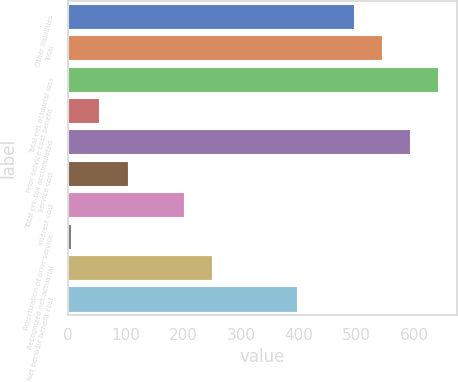Convert chart to OTSL. <chart><loc_0><loc_0><loc_500><loc_500><bar_chart><fcel>Other liabilities<fcel>Total<fcel>Total net actuarial loss<fcel>Prior service cost benefit<fcel>Total pre-tax accumulated<fcel>Service cost<fcel>Interest cost<fcel>Amortization of prior service<fcel>Recognized net actuarial<fcel>Net periodic benefit cost<nl><fcel>495<fcel>543.96<fcel>641.88<fcel>54.36<fcel>592.92<fcel>103.32<fcel>201.24<fcel>5.4<fcel>250.2<fcel>397.08<nl></chart> 